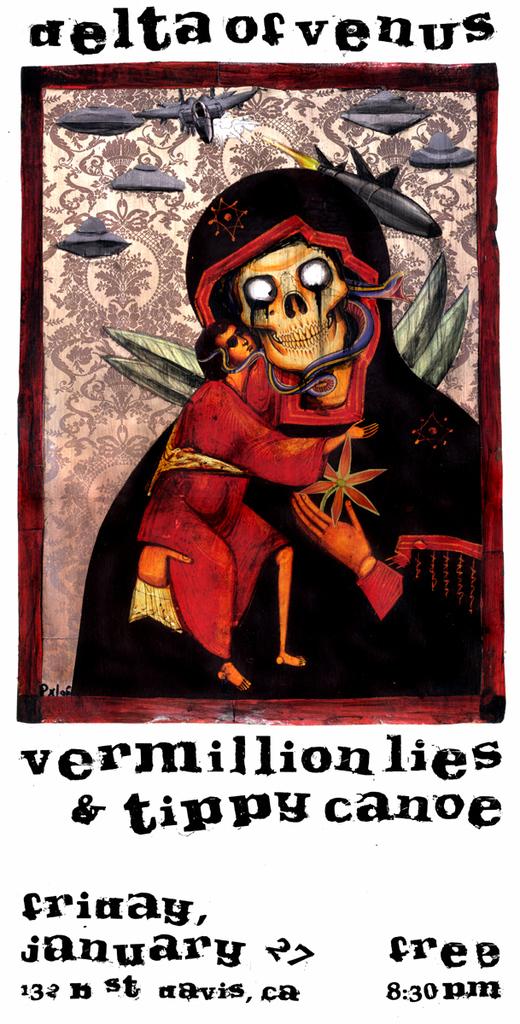Does this cost money to go to?
Offer a terse response. No. What time does the event start?
Keep it short and to the point. 8:30 pm. 